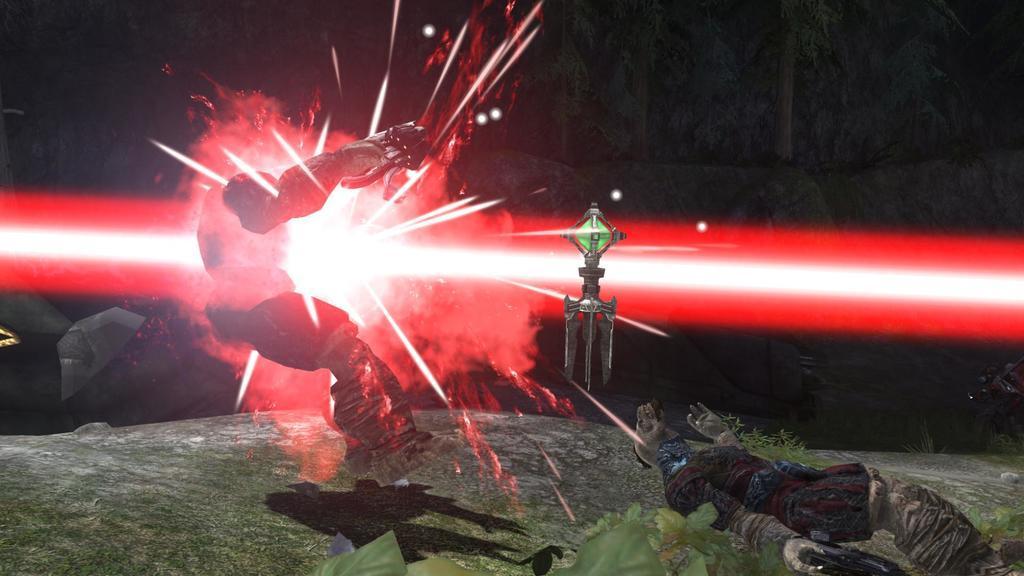Could you give a brief overview of what you see in this image? In this picture I can see I can see the depiction image, where I can see 2 cartoon characters and in the middle of this picture, I can see a green and silver color thing and I can see the red and white color light. I see that it is dark in the background. On the bottom side of this picture I can see the green color things. 